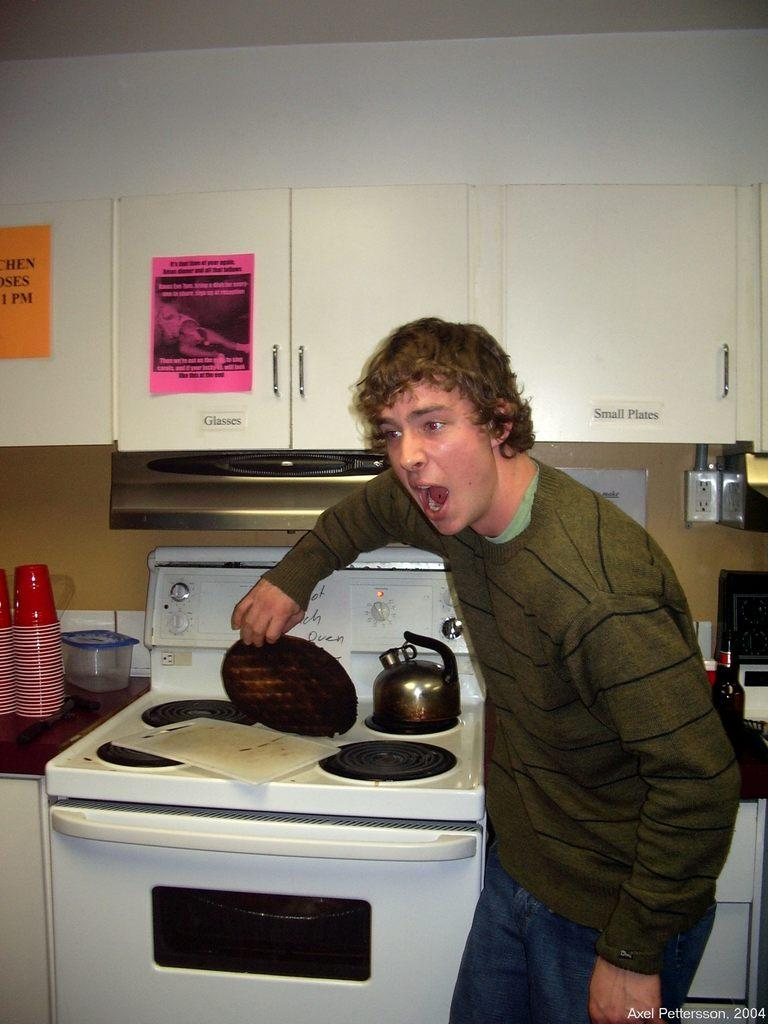<image>
Provide a brief description of the given image. A man in front of a stove and a cabinet labeled "Small Plates". 